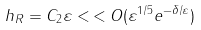Convert formula to latex. <formula><loc_0><loc_0><loc_500><loc_500>h _ { R } = C _ { 2 } \varepsilon < \, < O ( \varepsilon ^ { 1 / 5 } e ^ { - \delta / \varepsilon } )</formula> 